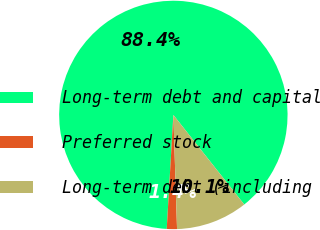<chart> <loc_0><loc_0><loc_500><loc_500><pie_chart><fcel>Long-term debt and capital<fcel>Preferred stock<fcel>Long-term debt (including<nl><fcel>88.42%<fcel>1.44%<fcel>10.14%<nl></chart> 